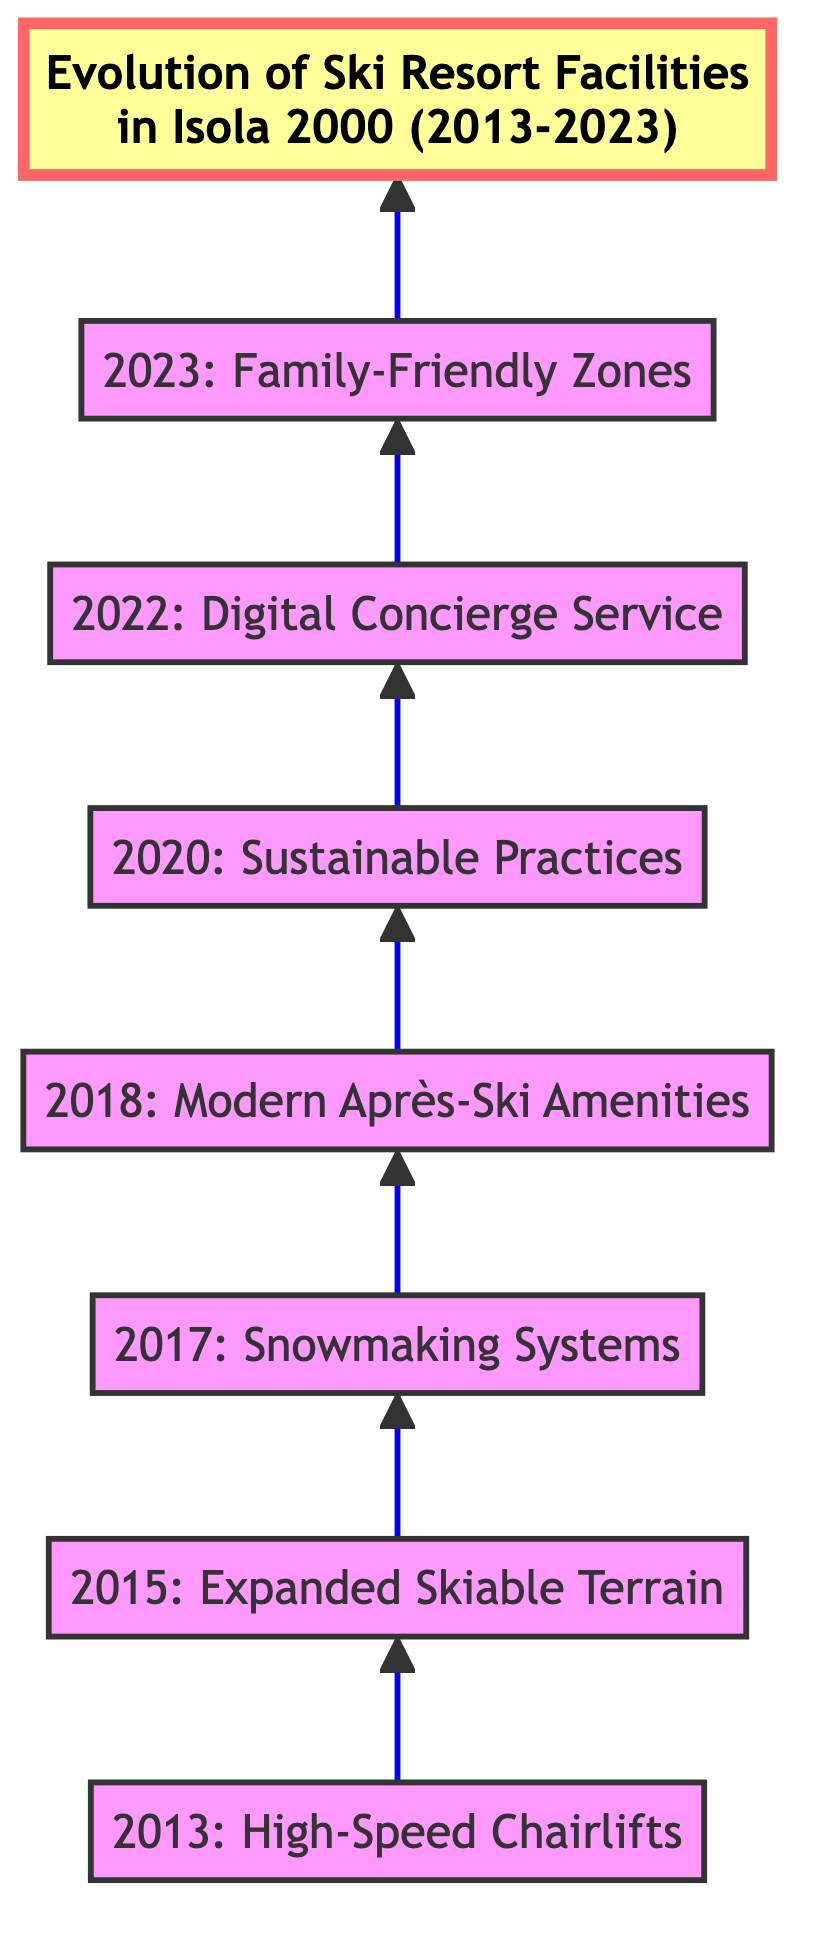What was introduced in 2013? The diagram indicates that in 2013, "High-Speed Chairlifts" were introduced as the first development.
Answer: High-Speed Chairlifts How many developments are listed in the diagram? By counting each individual node, there are a total of 7 developments from 2013 to 2023.
Answer: 7 What development follows the installation of snowmaking systems? The diagram shows that the development "Modernization of Après-Ski Amenities" follows directly after "Installation of Snowmaking Systems."
Answer: Modernization of Après-Ski Amenities Which year saw the introduction of sustainable practices? Looking at the nodes in the diagram, the node labeled "2020: Sustainable Practices" indicates that sustainable practices were introduced in 2020.
Answer: 2020 What is the last development mentioned in the diagram? The final node at the top of the diagram labeled "2023: Family-Friendly Zones" indicates that this is the last development mentioned.
Answer: Family-Friendly Zones What was the first development leading to the introduction of digital concierge service? The diagram shows that the introduction of "Sustainable Practices" in 2020 is the development leading to the introduction of the "Digital Concierge Service" in 2022.
Answer: Sustainable Practices How do the developments progress in the diagram? The diagram illustrates a bottom-to-top flow, suggesting that each development progresses chronologically from the bottom node upward to the top node.
Answer: Chronologically upward What significant enhancement was made in 2018? The node in the diagram for 2018 specifies the "Modernization of Après-Ski Amenities," highlighting this significant enhancement.
Answer: Modernization of Après-Ski Amenities What is indicated about the timing of the digital concierge service? The diagram specifies that the "Digital Concierge Service" was launched in 2022, indicating its timing.
Answer: 2022 